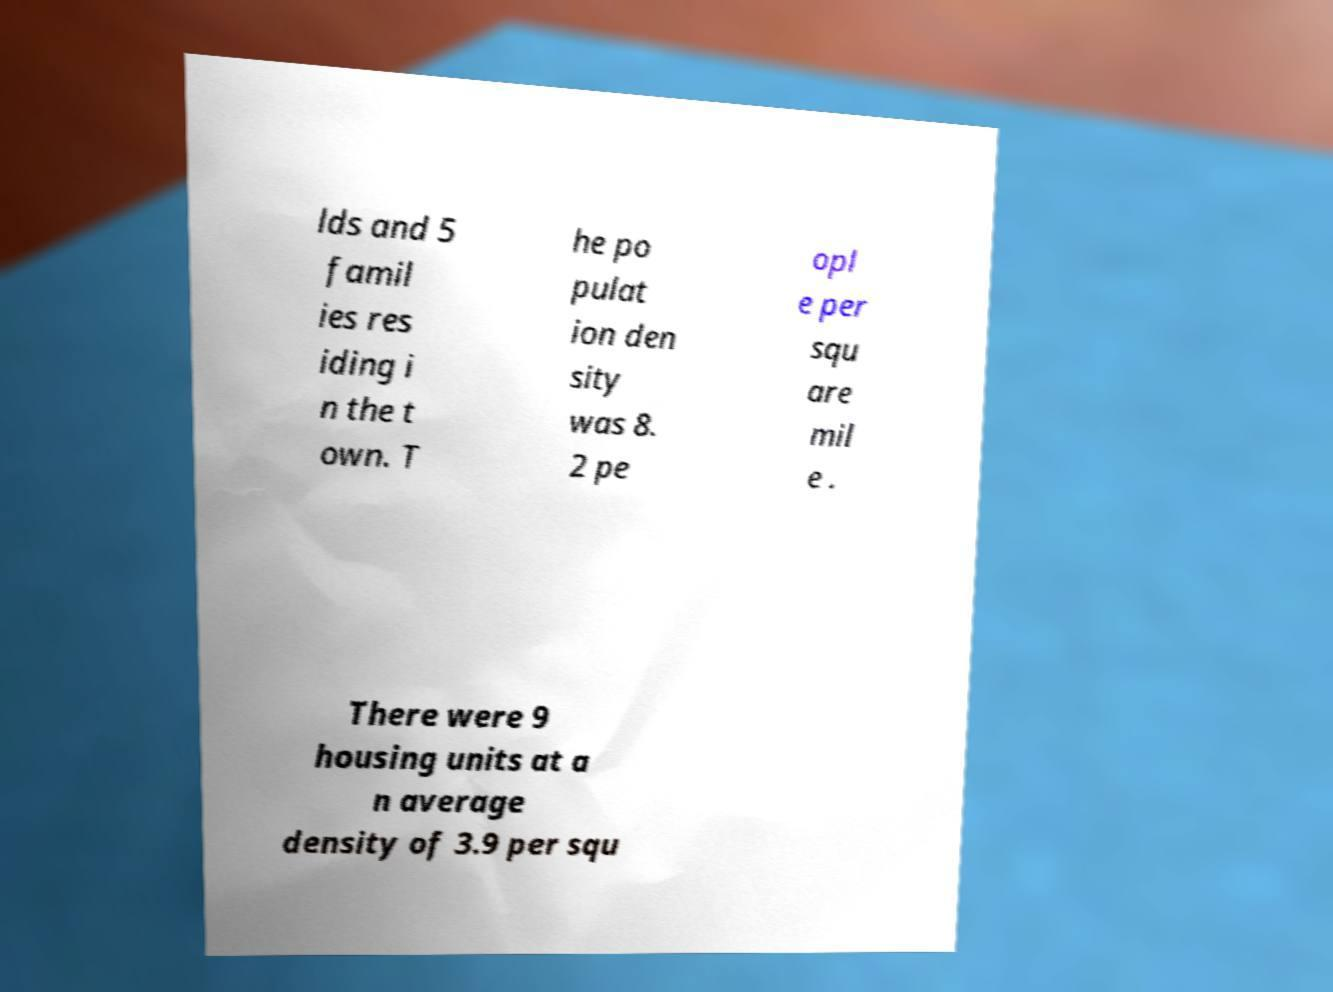What messages or text are displayed in this image? I need them in a readable, typed format. lds and 5 famil ies res iding i n the t own. T he po pulat ion den sity was 8. 2 pe opl e per squ are mil e . There were 9 housing units at a n average density of 3.9 per squ 